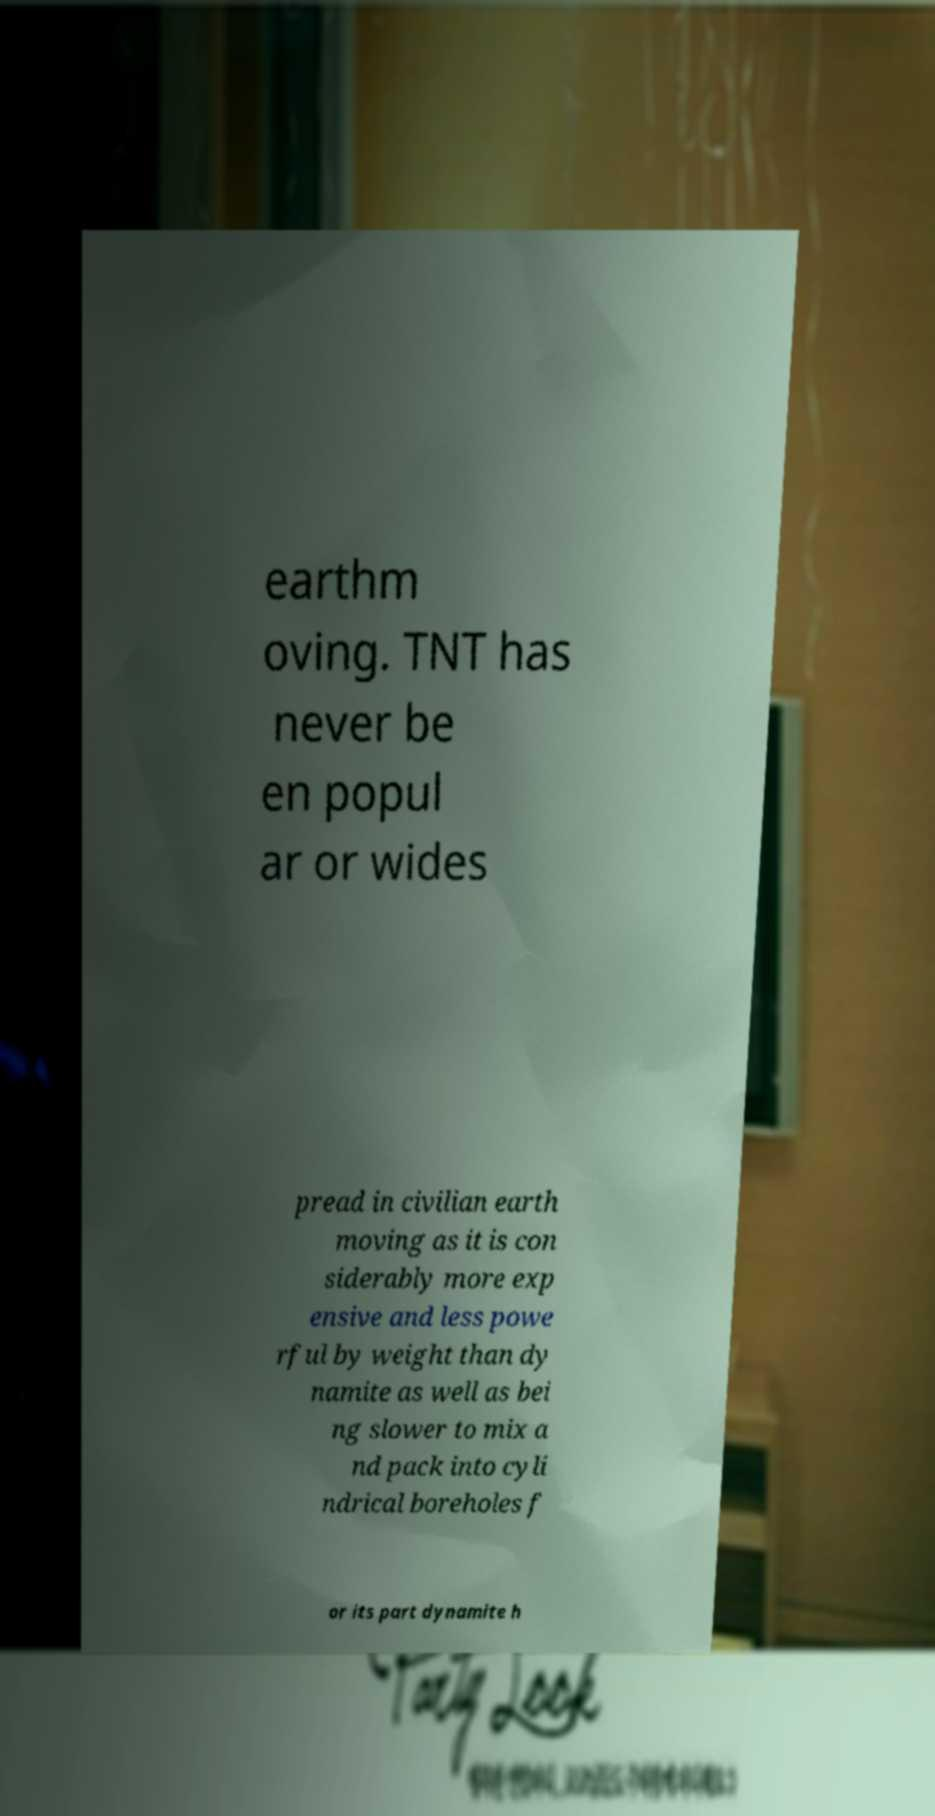For documentation purposes, I need the text within this image transcribed. Could you provide that? earthm oving. TNT has never be en popul ar or wides pread in civilian earth moving as it is con siderably more exp ensive and less powe rful by weight than dy namite as well as bei ng slower to mix a nd pack into cyli ndrical boreholes f or its part dynamite h 